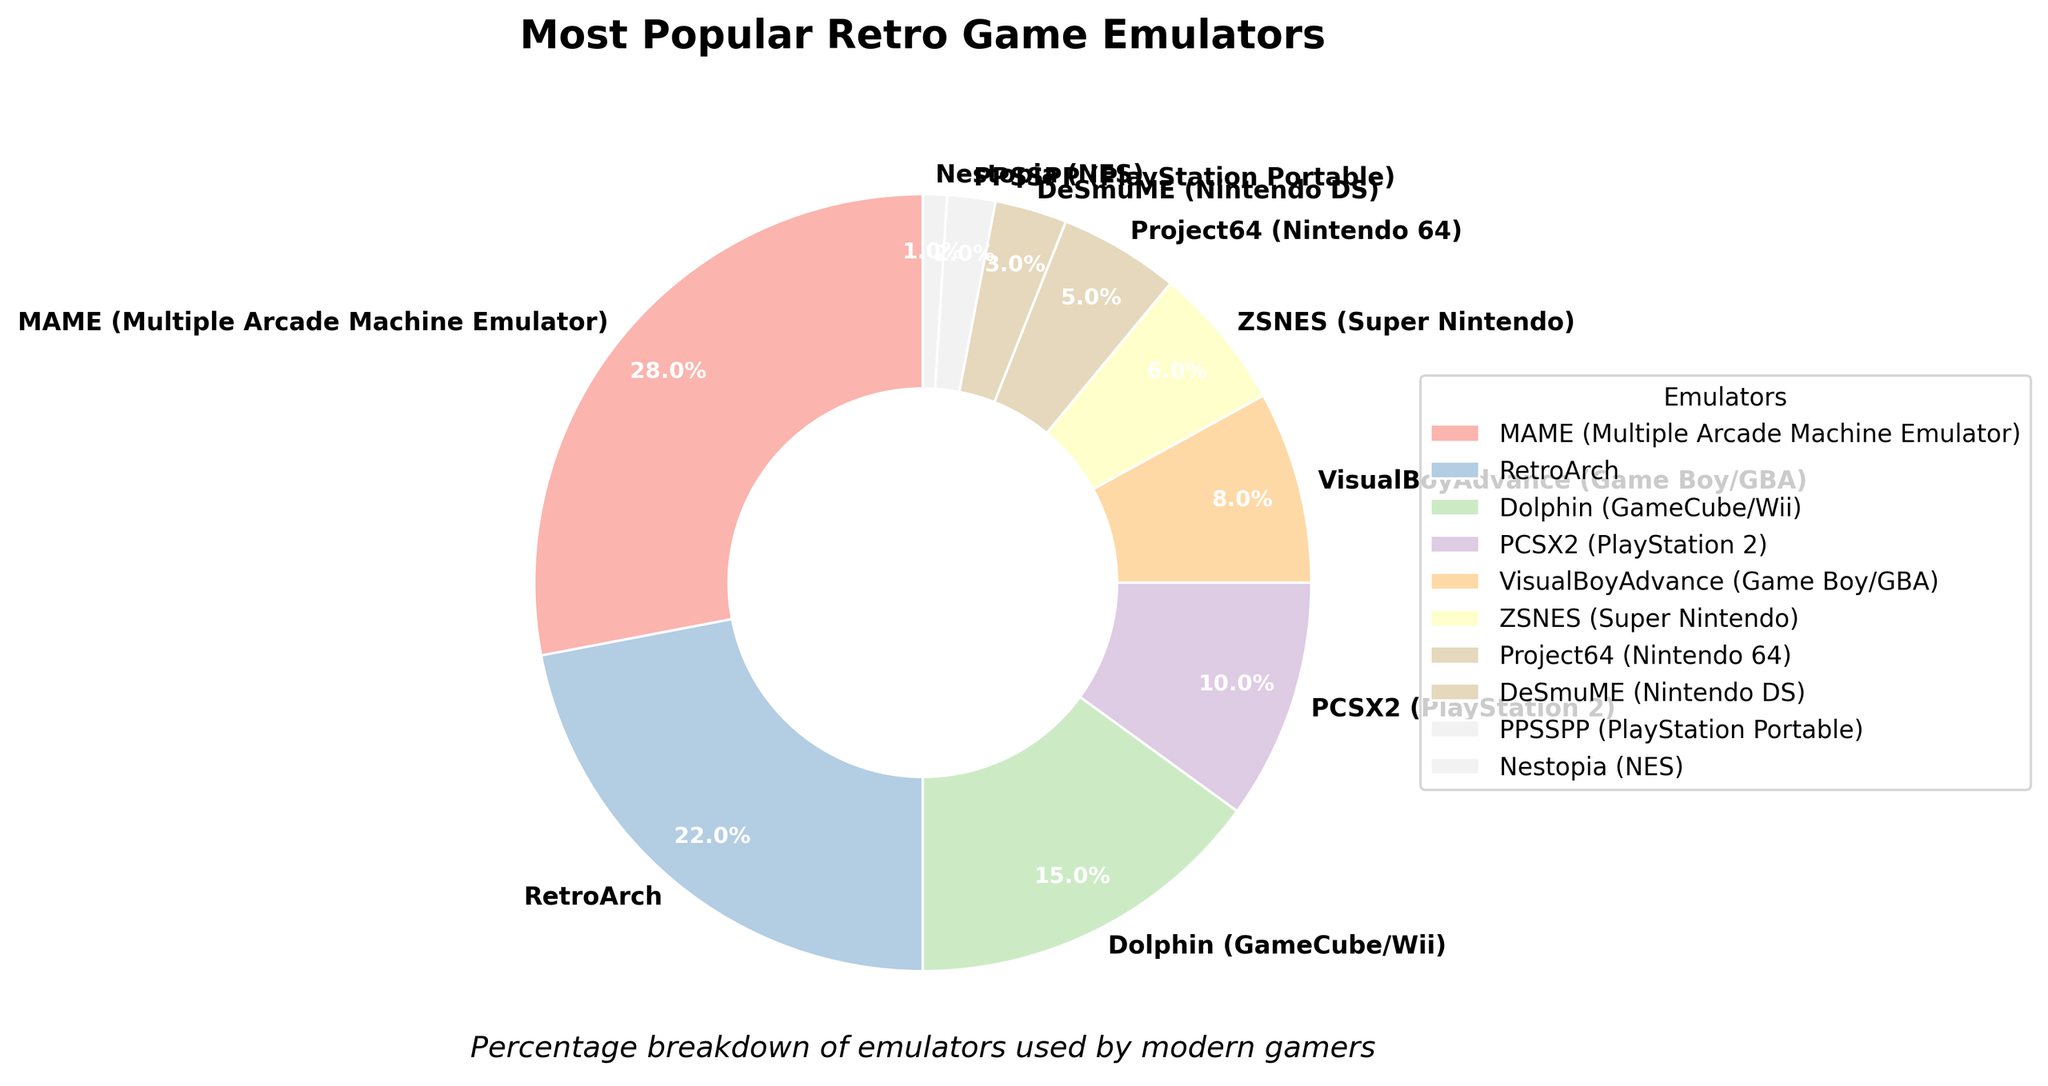Which emulator has the highest usage percentage? The pie chart shows that MAME (Multiple Arcade Machine Emulator) has the highest percentage at 28%.
Answer: MAME (28%) Which emulators have a usage percentage greater than 15%? By observing the chart, the emulators with usage percentages greater than 15% are MAME (28%), RetroArch (22%), and Dolphin (15%).
Answer: MAME, RetroArch, Dolphin What is the combined percentage usage of PCSX2, VisualBoyAdvance, and ZSNES? Refer to the chart to get the values: PCSX2 (10%), VisualBoyAdvance (8%), and ZSNES (6%). Adding them yields 10% + 8% + 6% = 24%.
Answer: 24% By how much does MAME's usage exceed RetroArch’s usage? MAME has 28% and RetroArch has 22%. Subtracting RetroArch’s percentage from MAME’s percentage: 28% - 22% = 6%.
Answer: 6% Which emulator has the lowest usage percentage, and what is that percentage? The pie chart indicates that Nestopia has the lowest usage at 1%.
Answer: Nestopia (1%) What is the total percentage share of emulators specific to Nintendo consoles (Dolphin, ZSNES, Project64, DeSmuME, and Nestopia)? Summing their percentages: Dolphin (15%) + ZSNES (6%) + Project64 (5%) + DeSmuME (3%) + Nestopia (1%) yields 15% + 6% + 5% + 3% + 1% = 30%.
Answer: 30% Is the percentage usage of Dolphin and PCSX2 combined greater than that of RetroArch? Adding Dolphin (15%) and PCSX2 (10%) results in 15% + 10% = 25%. RetroArch has 22%. Since 25% is greater than 22%, the combined percentage is greater.
Answer: Yes How many emulators have usage percentages less than 5%? The emulators with usage percentages less than 5% are DeSmuME (3%), PPSSPP (2%), and Nestopia (1%). Counting these gives 3 emulators.
Answer: 3 What is the percentage difference between the emulator with the highest usage and the one with the lowest usage? The highest usage is MAME at 28% and the lowest is Nestopia at 1%. The difference is 28% - 1% = 27%.
Answer: 27% Which emulator is represented by the lightest color visual in the pie chart, and what is its percentage? The pie chart uses lighter colors for lower percentages. Nestopia, with 1%, is likely represented by the lightest color.
Answer: Nestopia (1%) 